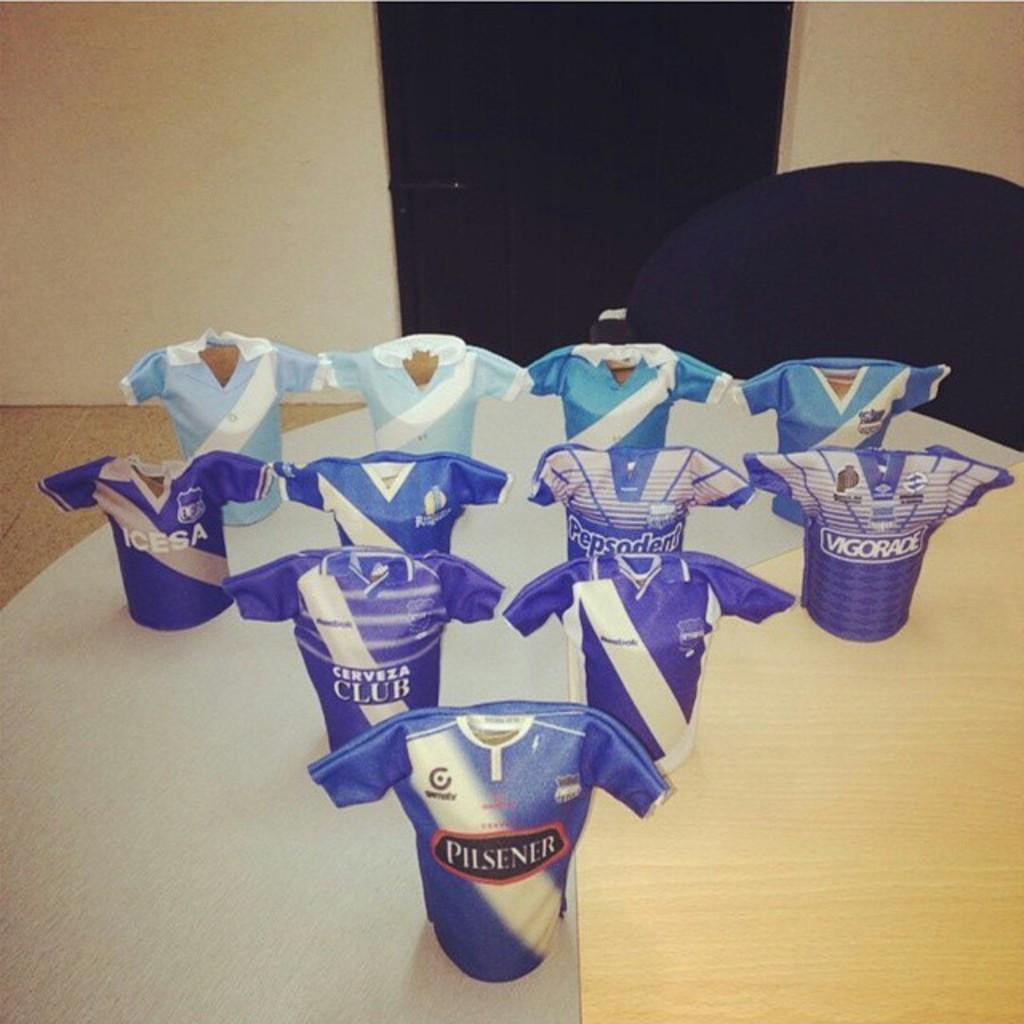Provide a one-sentence caption for the provided image. A blue shirt with pilsner on the font is in front of other blue shirts. 